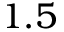Convert formula to latex. <formula><loc_0><loc_0><loc_500><loc_500>1 . 5</formula> 